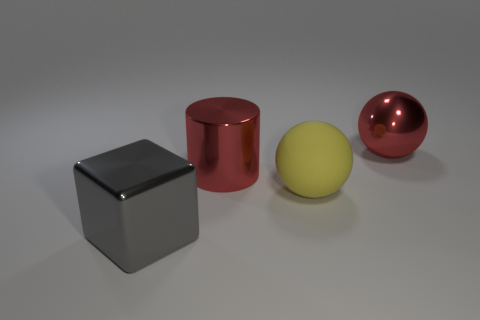Add 2 large red metallic balls. How many objects exist? 6 Subtract 1 spheres. How many spheres are left? 1 Subtract all cubes. How many objects are left? 3 Add 4 red spheres. How many red spheres are left? 5 Add 1 small gray metal things. How many small gray metal things exist? 1 Subtract 0 purple cylinders. How many objects are left? 4 Subtract all red blocks. Subtract all green spheres. How many blocks are left? 1 Subtract all blue cylinders. How many yellow spheres are left? 1 Subtract all small purple cylinders. Subtract all big yellow objects. How many objects are left? 3 